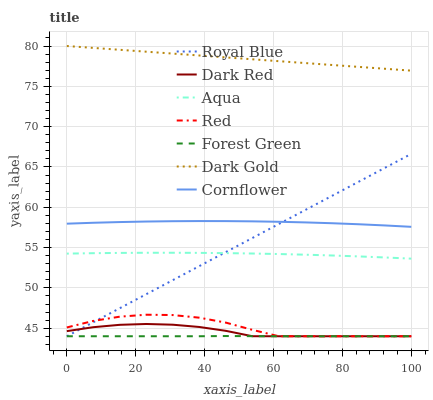Does Forest Green have the minimum area under the curve?
Answer yes or no. Yes. Does Dark Gold have the maximum area under the curve?
Answer yes or no. Yes. Does Dark Red have the minimum area under the curve?
Answer yes or no. No. Does Dark Red have the maximum area under the curve?
Answer yes or no. No. Is Royal Blue the smoothest?
Answer yes or no. Yes. Is Red the roughest?
Answer yes or no. Yes. Is Dark Gold the smoothest?
Answer yes or no. No. Is Dark Gold the roughest?
Answer yes or no. No. Does Dark Gold have the lowest value?
Answer yes or no. No. Does Dark Gold have the highest value?
Answer yes or no. Yes. Does Dark Red have the highest value?
Answer yes or no. No. Is Dark Red less than Dark Gold?
Answer yes or no. Yes. Is Dark Gold greater than Aqua?
Answer yes or no. Yes. Does Royal Blue intersect Aqua?
Answer yes or no. Yes. Is Royal Blue less than Aqua?
Answer yes or no. No. Is Royal Blue greater than Aqua?
Answer yes or no. No. Does Dark Red intersect Dark Gold?
Answer yes or no. No. 